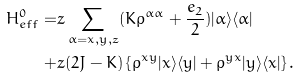Convert formula to latex. <formula><loc_0><loc_0><loc_500><loc_500>H _ { e f f } ^ { 0 } = & z \sum _ { \alpha = x , y , z } ( K \rho ^ { \alpha \alpha } + \frac { e _ { 2 } } { 2 } ) | \alpha \rangle \langle \alpha | \\ + & z ( 2 J - K ) \left \{ \rho ^ { x y } | x \rangle \langle y | + \rho ^ { y x } | y \rangle \langle x | \right \} .</formula> 